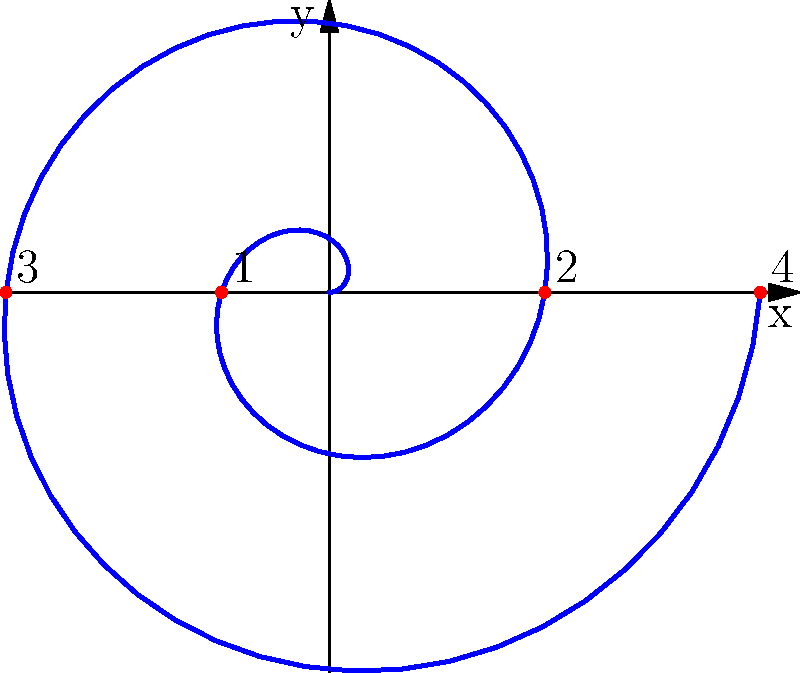As a dungeon master, you're designing a spiral dungeon layout using polar coordinates. The spiral is defined by the equation $r = 0.2\theta$, where $r$ is the distance from the center and $\theta$ is the angle in radians. If each full rotation represents a level of the dungeon, at which numbered point (1-4) would adventurers reach the third level of the dungeon? To solve this problem, let's break it down step-by-step:

1) Each full rotation of the spiral represents one level of the dungeon.
2) A full rotation in polar coordinates is $2\pi$ radians.
3) The third level would be completed after 3 full rotations.
4) Therefore, we need to find which point corresponds to $3 * 2\pi = 6\pi$ radians.

5) Looking at the given points:
   Point 1: $\theta = \pi$
   Point 2: $\theta = 2\pi$
   Point 3: $\theta = 3\pi$
   Point 4: $\theta = 4\pi$

6) The point we're looking for ($6\pi$) is between points 3 and 4.
7) Since we're asked about reaching the third level, we want the point just after completing 3 full rotations.

8) Therefore, the correct answer is point 4, which is just beyond $6\pi$ radians and represents the start of the fourth level (or the completion of the third level).
Answer: 4 